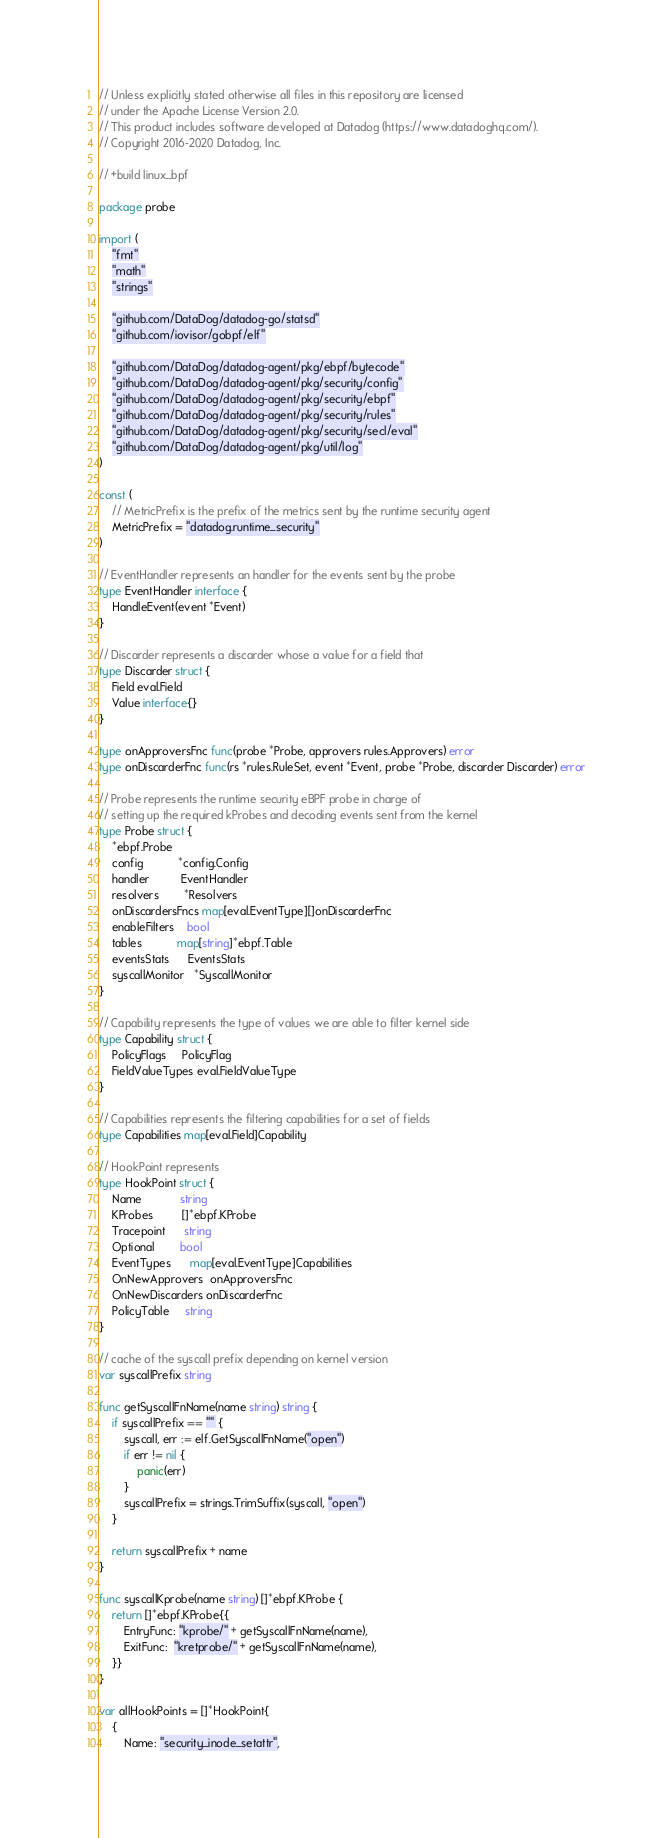<code> <loc_0><loc_0><loc_500><loc_500><_Go_>// Unless explicitly stated otherwise all files in this repository are licensed
// under the Apache License Version 2.0.
// This product includes software developed at Datadog (https://www.datadoghq.com/).
// Copyright 2016-2020 Datadog, Inc.

// +build linux_bpf

package probe

import (
	"fmt"
	"math"
	"strings"

	"github.com/DataDog/datadog-go/statsd"
	"github.com/iovisor/gobpf/elf"

	"github.com/DataDog/datadog-agent/pkg/ebpf/bytecode"
	"github.com/DataDog/datadog-agent/pkg/security/config"
	"github.com/DataDog/datadog-agent/pkg/security/ebpf"
	"github.com/DataDog/datadog-agent/pkg/security/rules"
	"github.com/DataDog/datadog-agent/pkg/security/secl/eval"
	"github.com/DataDog/datadog-agent/pkg/util/log"
)

const (
	// MetricPrefix is the prefix of the metrics sent by the runtime security agent
	MetricPrefix = "datadog.runtime_security"
)

// EventHandler represents an handler for the events sent by the probe
type EventHandler interface {
	HandleEvent(event *Event)
}

// Discarder represents a discarder whose a value for a field that
type Discarder struct {
	Field eval.Field
	Value interface{}
}

type onApproversFnc func(probe *Probe, approvers rules.Approvers) error
type onDiscarderFnc func(rs *rules.RuleSet, event *Event, probe *Probe, discarder Discarder) error

// Probe represents the runtime security eBPF probe in charge of
// setting up the required kProbes and decoding events sent from the kernel
type Probe struct {
	*ebpf.Probe
	config           *config.Config
	handler          EventHandler
	resolvers        *Resolvers
	onDiscardersFncs map[eval.EventType][]onDiscarderFnc
	enableFilters    bool
	tables           map[string]*ebpf.Table
	eventsStats      EventsStats
	syscallMonitor   *SyscallMonitor
}

// Capability represents the type of values we are able to filter kernel side
type Capability struct {
	PolicyFlags     PolicyFlag
	FieldValueTypes eval.FieldValueType
}

// Capabilities represents the filtering capabilities for a set of fields
type Capabilities map[eval.Field]Capability

// HookPoint represents
type HookPoint struct {
	Name            string
	KProbes         []*ebpf.KProbe
	Tracepoint      string
	Optional        bool
	EventTypes      map[eval.EventType]Capabilities
	OnNewApprovers  onApproversFnc
	OnNewDiscarders onDiscarderFnc
	PolicyTable     string
}

// cache of the syscall prefix depending on kernel version
var syscallPrefix string

func getSyscallFnName(name string) string {
	if syscallPrefix == "" {
		syscall, err := elf.GetSyscallFnName("open")
		if err != nil {
			panic(err)
		}
		syscallPrefix = strings.TrimSuffix(syscall, "open")
	}

	return syscallPrefix + name
}

func syscallKprobe(name string) []*ebpf.KProbe {
	return []*ebpf.KProbe{{
		EntryFunc: "kprobe/" + getSyscallFnName(name),
		ExitFunc:  "kretprobe/" + getSyscallFnName(name),
	}}
}

var allHookPoints = []*HookPoint{
	{
		Name: "security_inode_setattr",</code> 